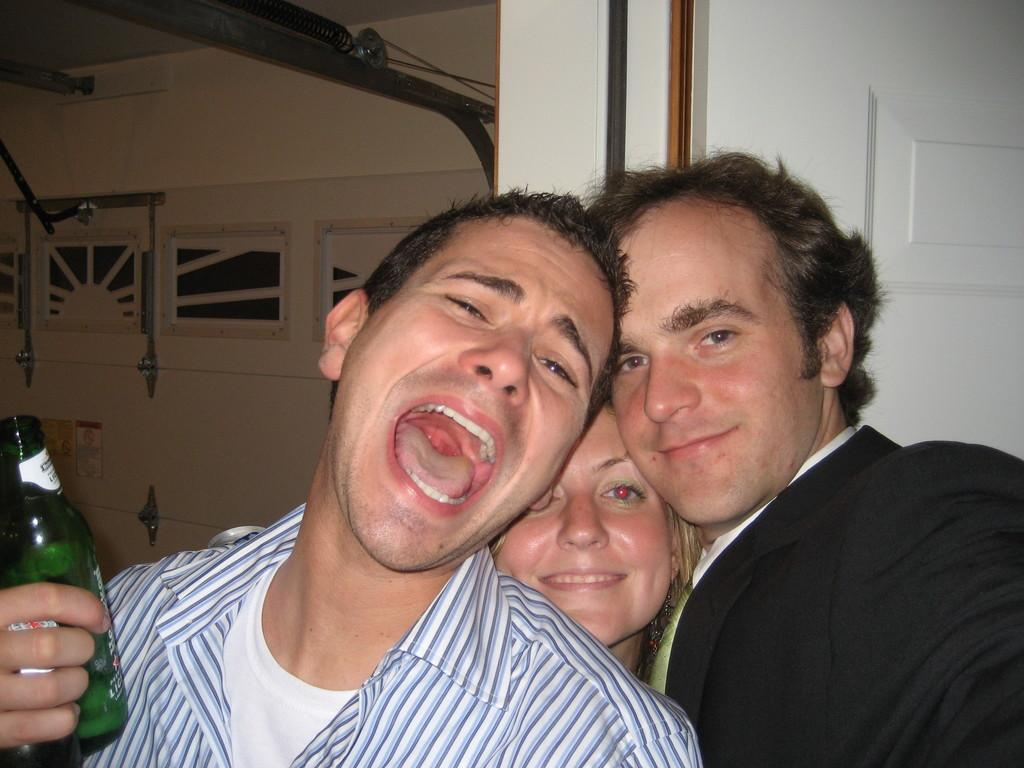What is the main subject of the image? There is a person standing in the image. What is the person holding in his hands? The person is holding a green color bottle in his hands. Are there any other people visible in the image? Yes, there are two people standing on the right side of the image. What type of frogs can be seen participating in the feast in the image? There are no frogs or feast present in the image. Is there a ship visible in the image? There is no ship visible in the image. 